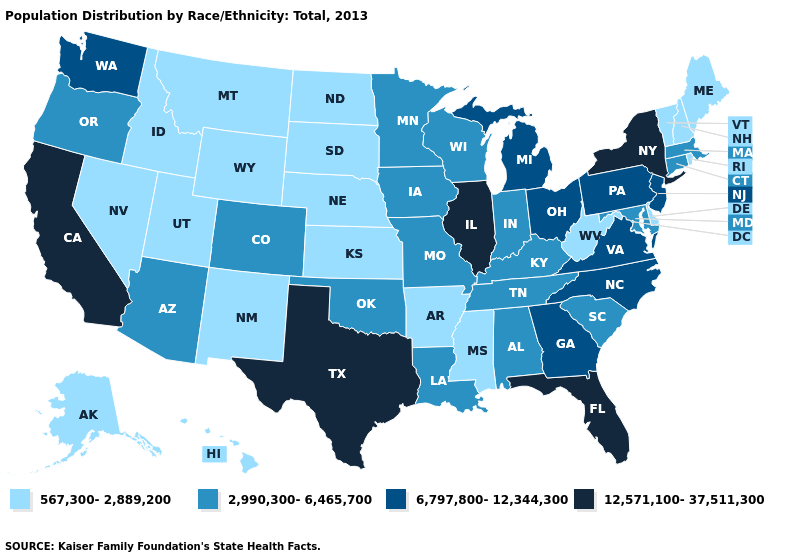What is the value of Pennsylvania?
Quick response, please. 6,797,800-12,344,300. Which states have the highest value in the USA?
Give a very brief answer. California, Florida, Illinois, New York, Texas. Name the states that have a value in the range 567,300-2,889,200?
Write a very short answer. Alaska, Arkansas, Delaware, Hawaii, Idaho, Kansas, Maine, Mississippi, Montana, Nebraska, Nevada, New Hampshire, New Mexico, North Dakota, Rhode Island, South Dakota, Utah, Vermont, West Virginia, Wyoming. What is the lowest value in the MidWest?
Short answer required. 567,300-2,889,200. Name the states that have a value in the range 567,300-2,889,200?
Write a very short answer. Alaska, Arkansas, Delaware, Hawaii, Idaho, Kansas, Maine, Mississippi, Montana, Nebraska, Nevada, New Hampshire, New Mexico, North Dakota, Rhode Island, South Dakota, Utah, Vermont, West Virginia, Wyoming. What is the highest value in the USA?
Be succinct. 12,571,100-37,511,300. Name the states that have a value in the range 12,571,100-37,511,300?
Short answer required. California, Florida, Illinois, New York, Texas. Among the states that border Kentucky , does West Virginia have the highest value?
Concise answer only. No. Among the states that border Missouri , which have the lowest value?
Give a very brief answer. Arkansas, Kansas, Nebraska. How many symbols are there in the legend?
Give a very brief answer. 4. Does Massachusetts have a higher value than New Hampshire?
Give a very brief answer. Yes. Among the states that border Connecticut , does New York have the lowest value?
Give a very brief answer. No. Name the states that have a value in the range 567,300-2,889,200?
Quick response, please. Alaska, Arkansas, Delaware, Hawaii, Idaho, Kansas, Maine, Mississippi, Montana, Nebraska, Nevada, New Hampshire, New Mexico, North Dakota, Rhode Island, South Dakota, Utah, Vermont, West Virginia, Wyoming. 